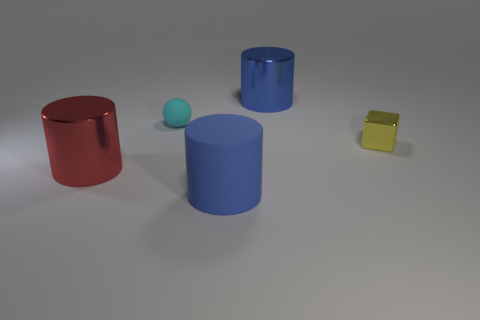Are there more cyan rubber objects behind the tiny metal object than green rubber blocks?
Offer a very short reply. Yes. What number of things are either cyan spheres or big cylinders that are to the right of the tiny cyan rubber ball?
Offer a very short reply. 3. Is the number of blue shiny objects behind the tiny cyan sphere greater than the number of big rubber things that are on the left side of the blue rubber thing?
Keep it short and to the point. Yes. What material is the object that is to the right of the large thing that is behind the large metallic cylinder that is in front of the blue metallic cylinder made of?
Your response must be concise. Metal. What shape is the blue thing that is made of the same material as the cyan object?
Keep it short and to the point. Cylinder. Are there any tiny metallic things right of the big blue cylinder that is in front of the cyan object?
Your response must be concise. Yes. How big is the rubber cylinder?
Your response must be concise. Large. How many objects are rubber cylinders or blue things?
Your answer should be very brief. 2. Do the object that is behind the small cyan object and the thing that is to the left of the tiny cyan rubber sphere have the same material?
Your answer should be very brief. Yes. What is the color of the big cylinder that is the same material as the ball?
Ensure brevity in your answer.  Blue. 